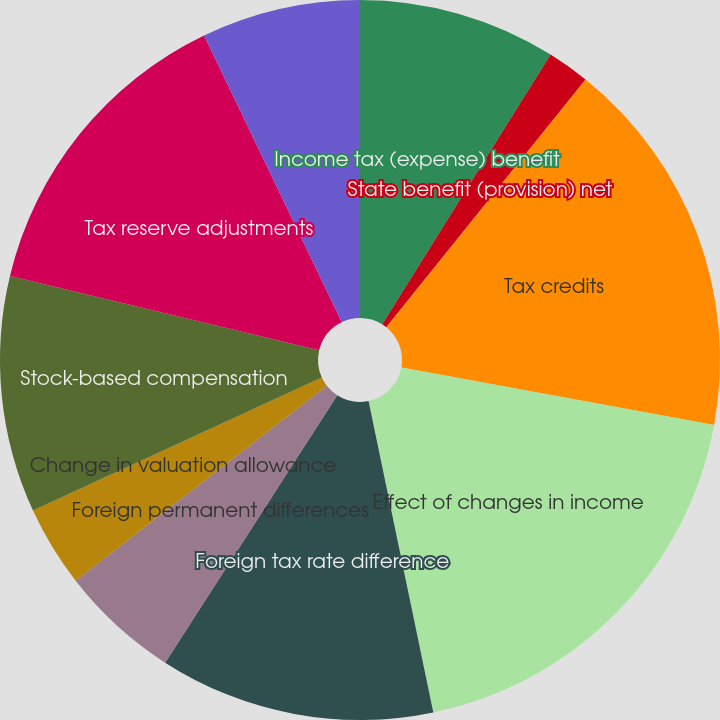<chart> <loc_0><loc_0><loc_500><loc_500><pie_chart><fcel>Income tax (expense) benefit<fcel>State benefit (provision) net<fcel>Tax credits<fcel>Effect of changes in income<fcel>Foreign tax rate difference<fcel>Foreign permanent differences<fcel>Change in valuation allowance<fcel>Stock-based compensation<fcel>Tax reserve adjustments<fcel>Actual and deemed dividend<nl><fcel>8.88%<fcel>1.9%<fcel>17.11%<fcel>18.85%<fcel>12.37%<fcel>5.39%<fcel>3.64%<fcel>10.62%<fcel>14.12%<fcel>7.13%<nl></chart> 